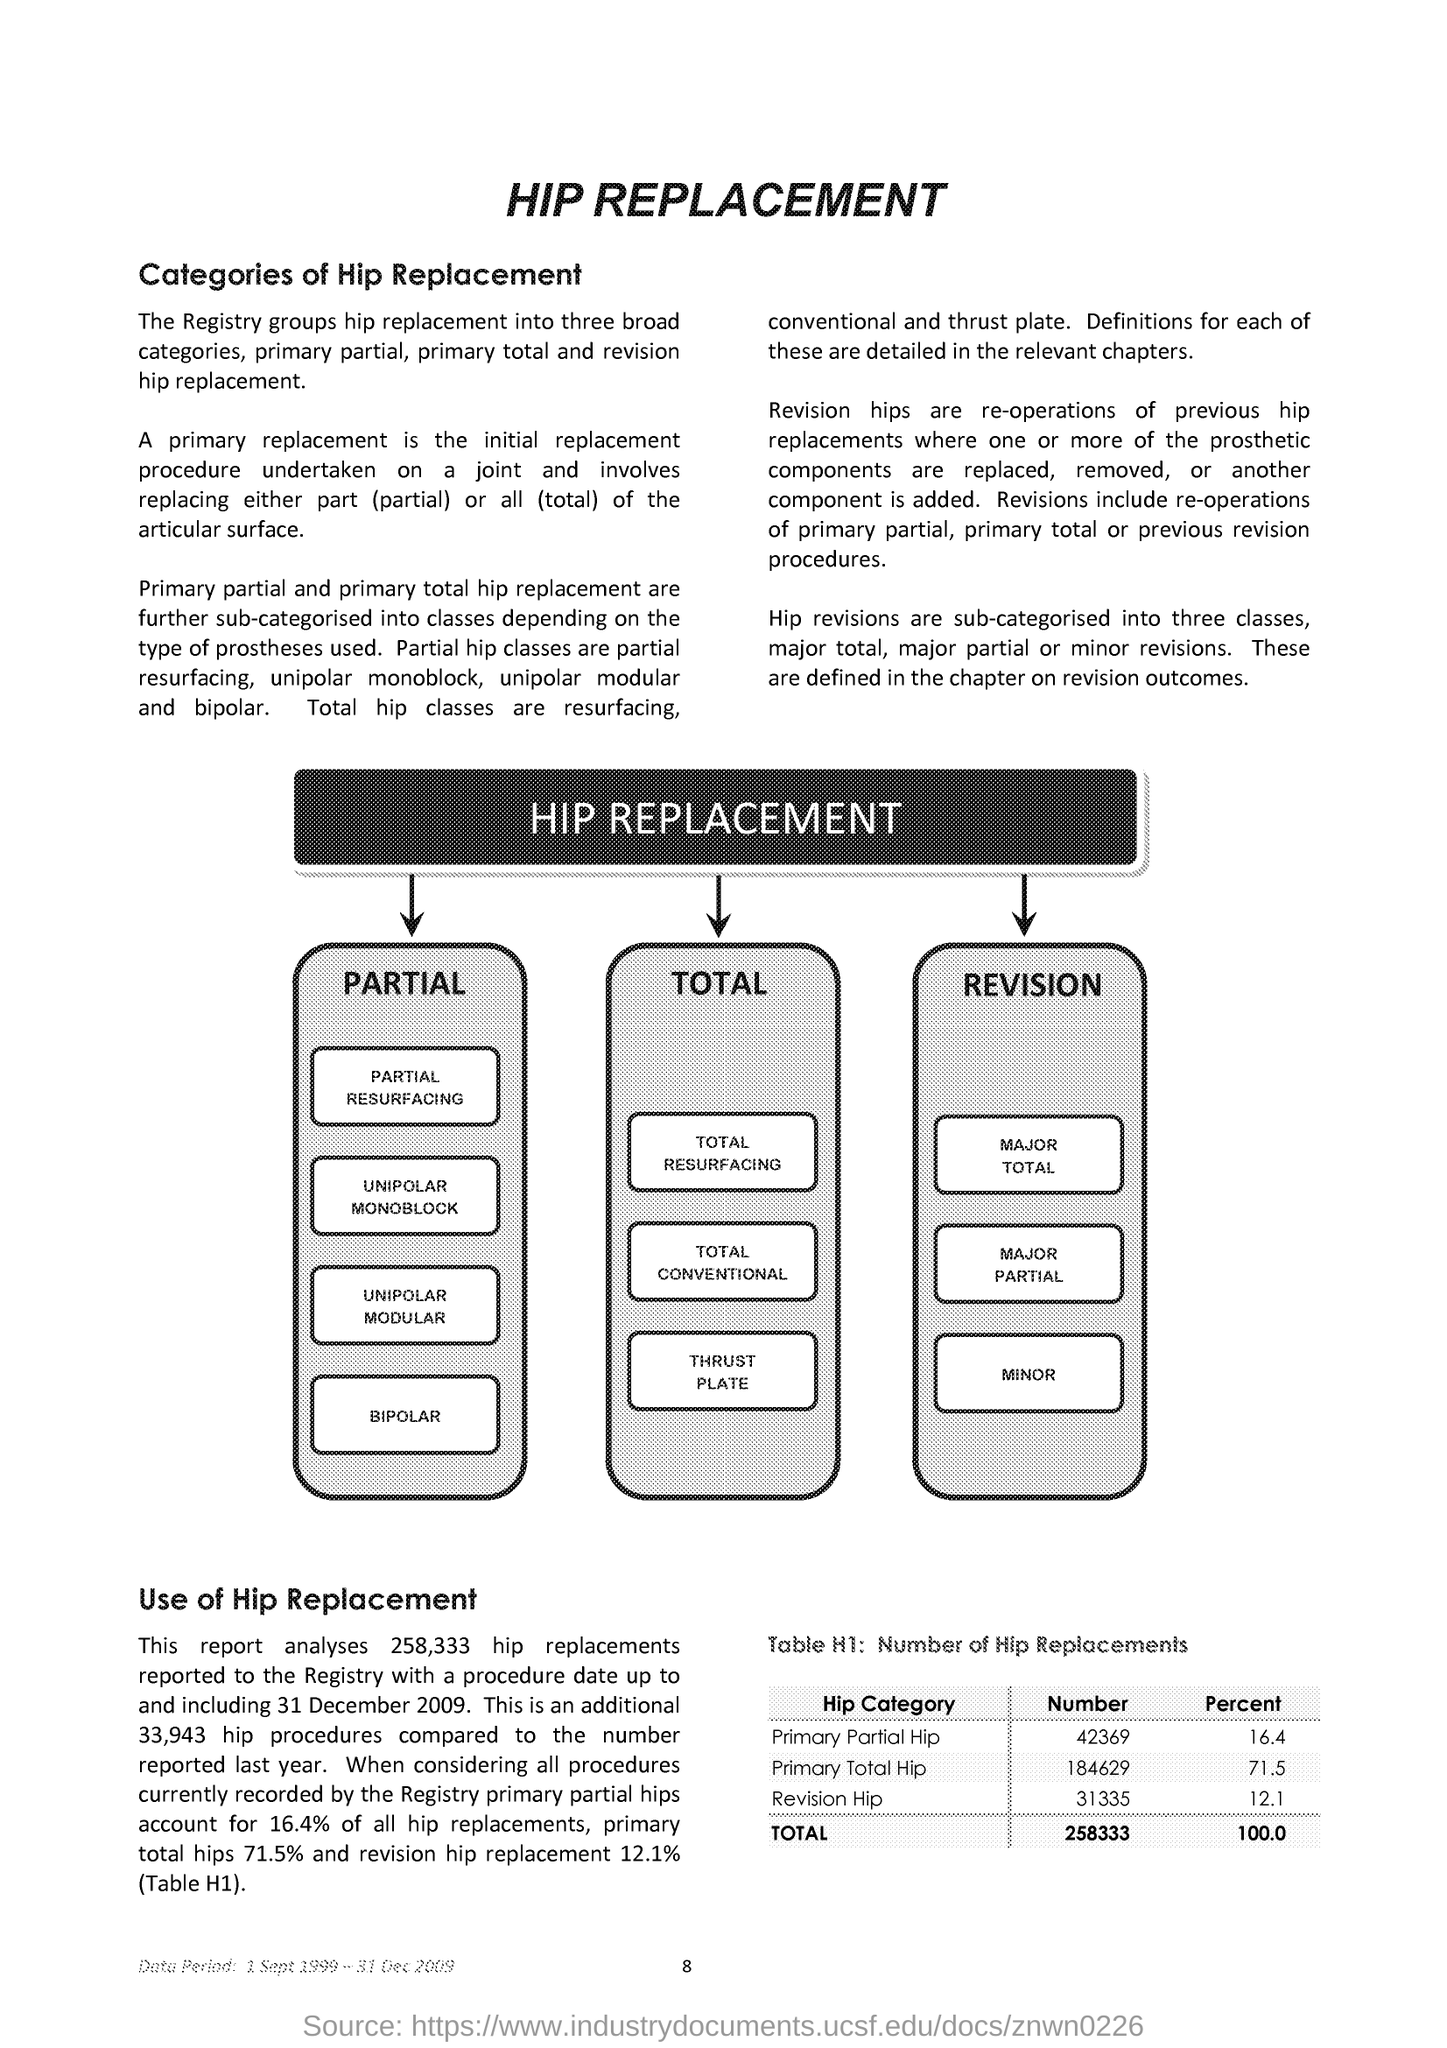What does Table H1 describe?
Your answer should be compact. Number of Hip Replacements. What is the total no of hip replacements reported as given in Table H1?
Give a very brief answer. 258333. What percent of primary partial hips account for all hip replacements?
Ensure brevity in your answer.  16 4. What percent of primary total hips account for all hip replacements?
Your answer should be very brief. 71.5. 